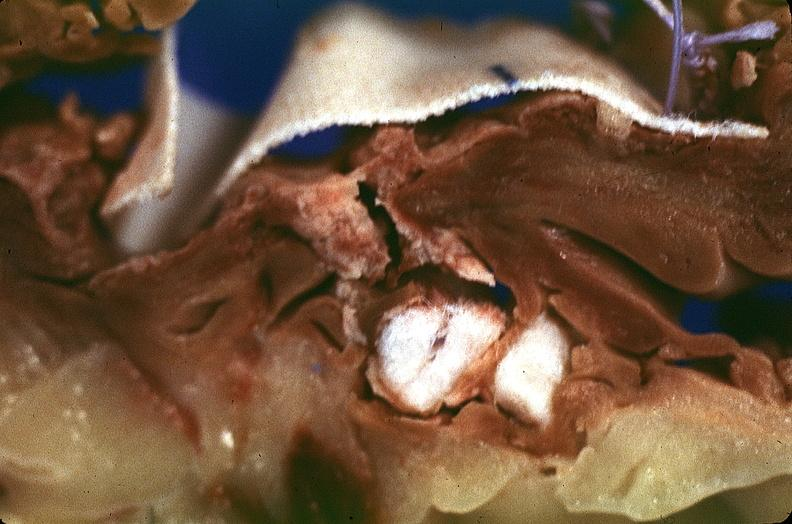where is this?
Answer the question using a single word or phrase. Heart 